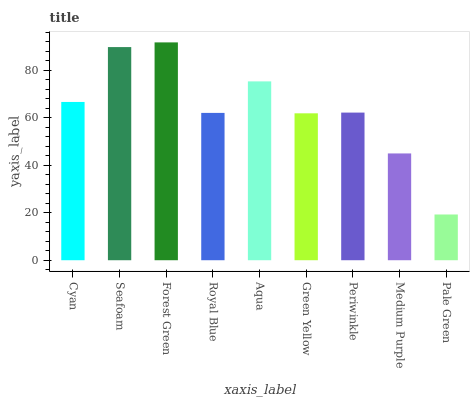Is Seafoam the minimum?
Answer yes or no. No. Is Seafoam the maximum?
Answer yes or no. No. Is Seafoam greater than Cyan?
Answer yes or no. Yes. Is Cyan less than Seafoam?
Answer yes or no. Yes. Is Cyan greater than Seafoam?
Answer yes or no. No. Is Seafoam less than Cyan?
Answer yes or no. No. Is Periwinkle the high median?
Answer yes or no. Yes. Is Periwinkle the low median?
Answer yes or no. Yes. Is Cyan the high median?
Answer yes or no. No. Is Cyan the low median?
Answer yes or no. No. 